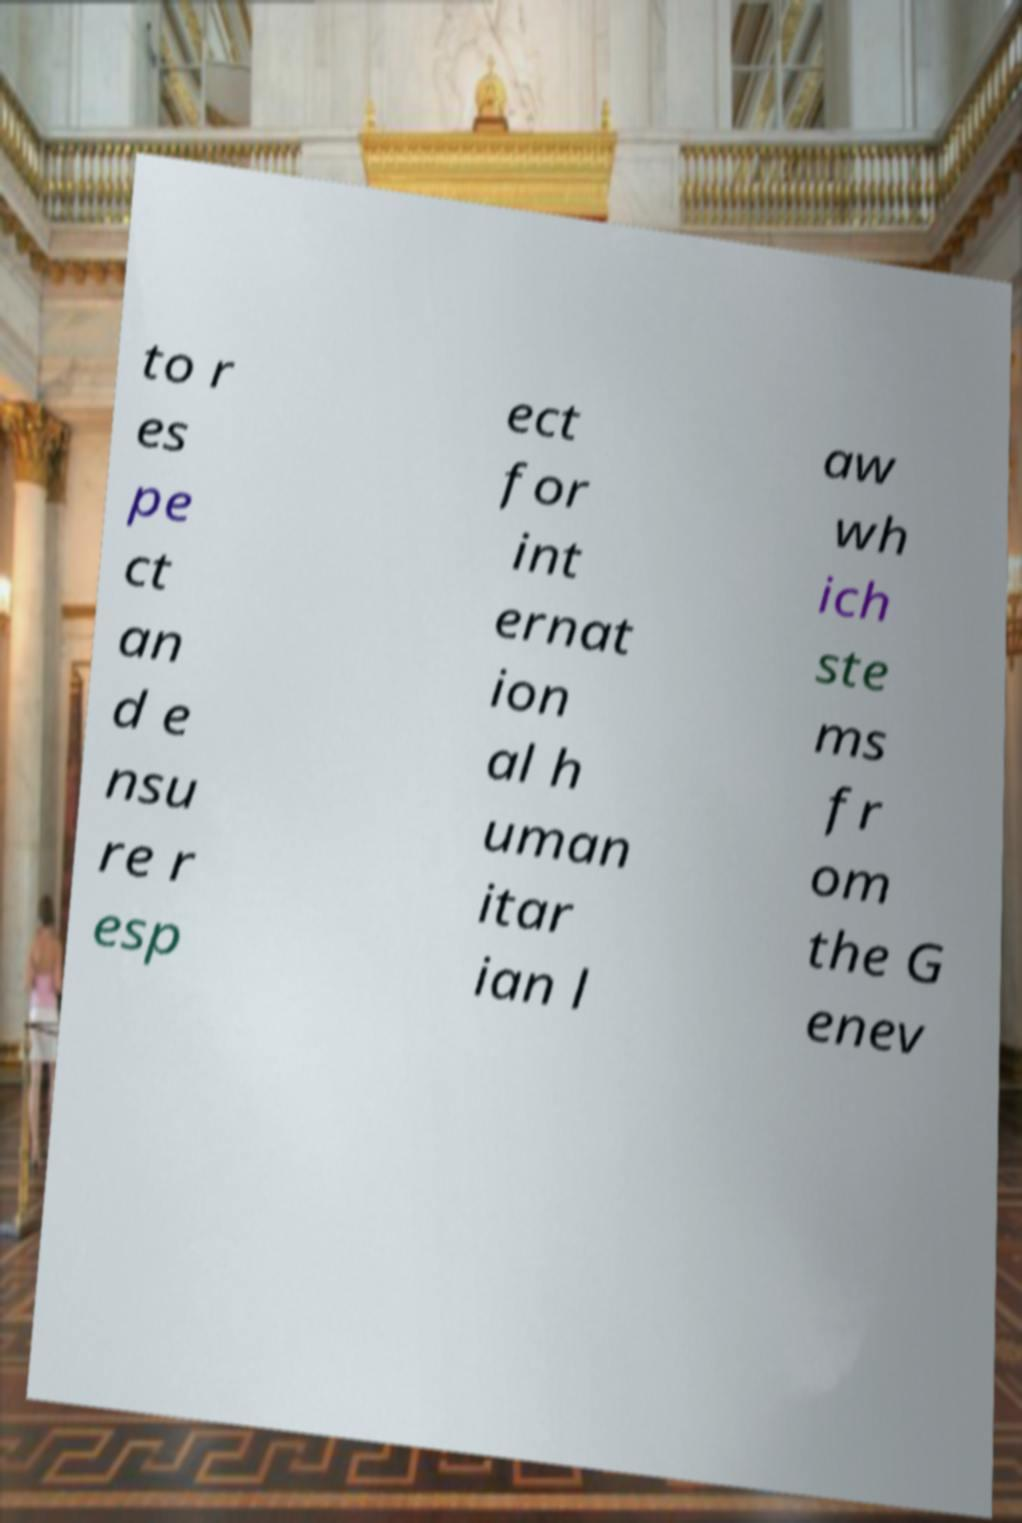Could you assist in decoding the text presented in this image and type it out clearly? to r es pe ct an d e nsu re r esp ect for int ernat ion al h uman itar ian l aw wh ich ste ms fr om the G enev 